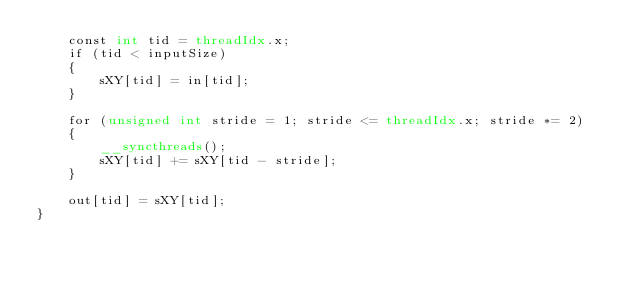Convert code to text. <code><loc_0><loc_0><loc_500><loc_500><_Cuda_>    const int tid = threadIdx.x;
    if (tid < inputSize)
    {
        sXY[tid] = in[tid];
    }

    for (unsigned int stride = 1; stride <= threadIdx.x; stride *= 2)
    {
        __syncthreads();
        sXY[tid] += sXY[tid - stride];
    }

    out[tid] = sXY[tid];
}</code> 